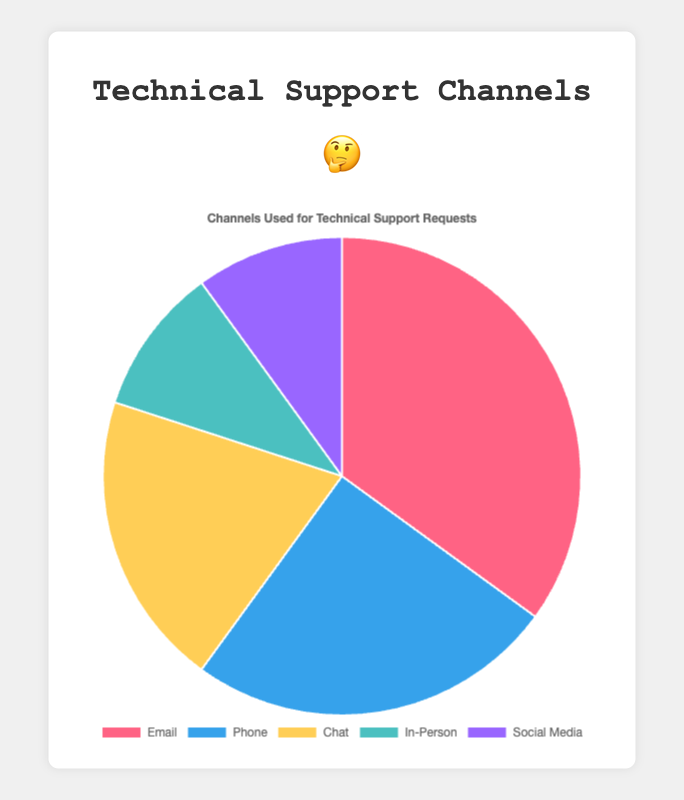what percent of requests are received by email compared to the total? To find the percentage, divide the number of email requests by the total number of requests and multiply by 100. That is (35 / (35 + 25 + 20 + 10 + 10)) * 100. The total number of requests is 100, so the percentage is (35 / 100) * 100 = 35%.
Answer: 35% which two channels have the same number of requests? According to the pie chart, "In-Person" and "Social Media" both have 10 requests.
Answer: In-Person and Social Media how do phone requests compare to chat requests? Phone requests are compared to chat requests. Phones have 25 requests, and chat has 20 requests. Thus, phone requests are greater than chat requests.
Answer: Phone is greater than chat what is the total percent of requests received via in-person and social media channels? First, sum the requests for In-Person and Social Media, which is 10 + 10 = 20. Then, calculate the percentage of total requests, which is (20 / 100) * 100 = 20%.
Answer: 20% which channel has the highest number of requests and how many more requests does it have than chat? Email has the highest number of requests with 35. It has 35 - 20 = 15 more requests than Chat.
Answer: Email has 15 more than Chat what support channel has the least number of requests? Both "In-Person" and "Social Media" have the least number of requests, each with 10.
Answer: In-Person and Social Media what is the combined percentage of phone and chat requests? Sum the requests for Phone and Chat which is 25 + 20 = 45. The percentage of total requests is (45 / 100) * 100 = 45%.
Answer: 45% which channel is represented by the red color slice? The red color slice represents the "Email" channel.
Answer: Email 